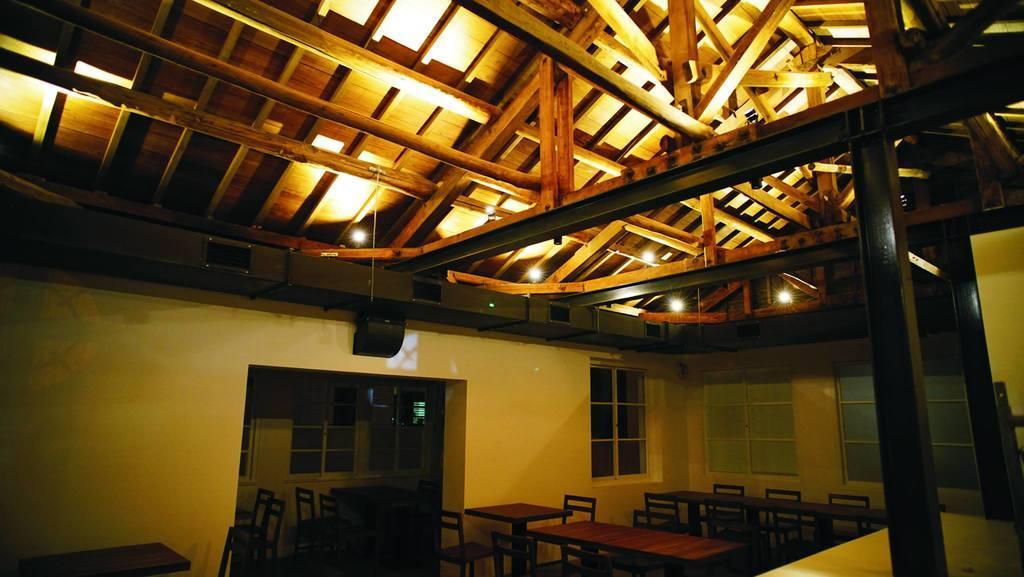In one or two sentences, can you explain what this image depicts? In this image at the bottom there are some tables and chairs, on the right side there are windows and on the top there are some wooden sticks and ceiling and some lights. On the right side there is one wooden pole, and in the background there are some windows. 